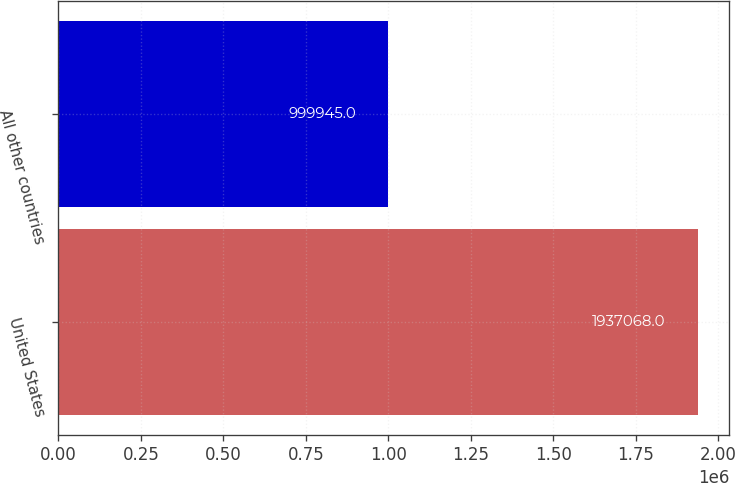Convert chart to OTSL. <chart><loc_0><loc_0><loc_500><loc_500><bar_chart><fcel>United States<fcel>All other countries<nl><fcel>1.93707e+06<fcel>999945<nl></chart> 